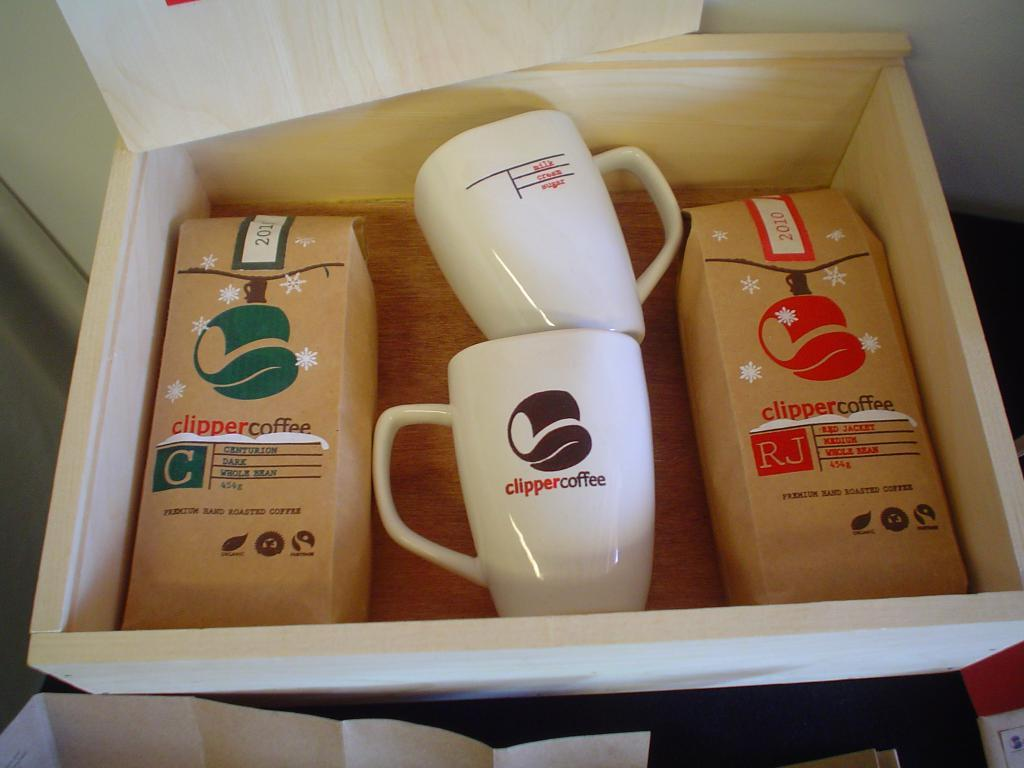Provide a one-sentence caption for the provided image. a wood box of clipper coffee and mugs. 